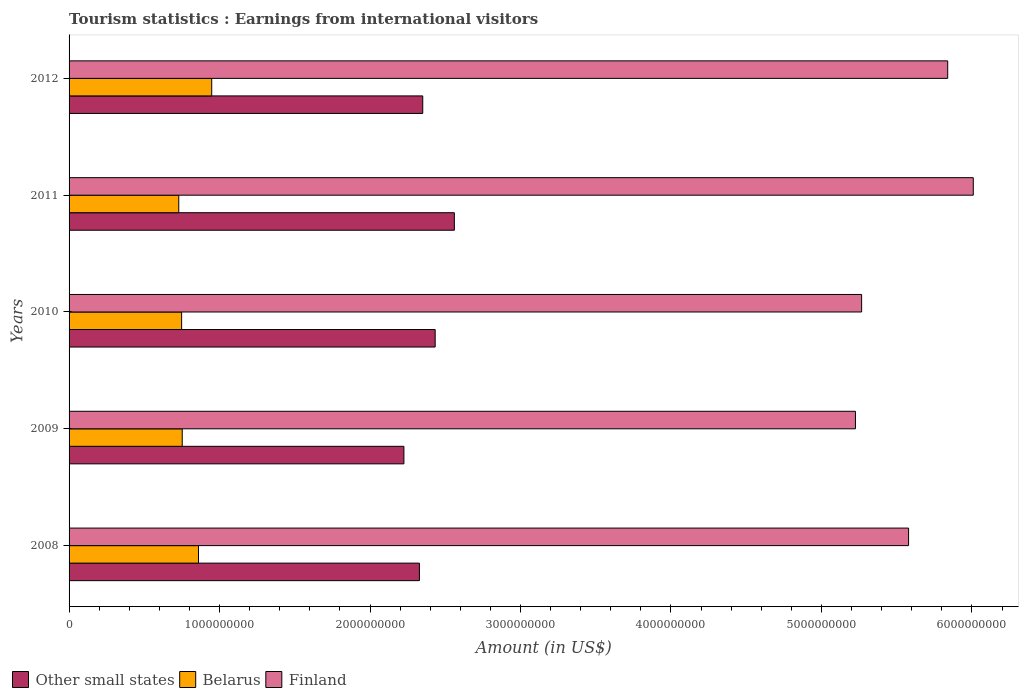How many different coloured bars are there?
Give a very brief answer. 3. Are the number of bars on each tick of the Y-axis equal?
Your answer should be compact. Yes. How many bars are there on the 4th tick from the bottom?
Offer a very short reply. 3. What is the label of the 1st group of bars from the top?
Your response must be concise. 2012. In how many cases, is the number of bars for a given year not equal to the number of legend labels?
Provide a succinct answer. 0. What is the earnings from international visitors in Other small states in 2012?
Provide a short and direct response. 2.35e+09. Across all years, what is the maximum earnings from international visitors in Other small states?
Offer a terse response. 2.56e+09. Across all years, what is the minimum earnings from international visitors in Other small states?
Ensure brevity in your answer.  2.23e+09. In which year was the earnings from international visitors in Other small states minimum?
Ensure brevity in your answer.  2009. What is the total earnings from international visitors in Finland in the graph?
Provide a short and direct response. 2.79e+1. What is the difference between the earnings from international visitors in Other small states in 2009 and that in 2010?
Provide a short and direct response. -2.08e+08. What is the difference between the earnings from international visitors in Belarus in 2008 and the earnings from international visitors in Finland in 2012?
Your answer should be compact. -4.98e+09. What is the average earnings from international visitors in Finland per year?
Keep it short and to the point. 5.58e+09. In the year 2011, what is the difference between the earnings from international visitors in Other small states and earnings from international visitors in Finland?
Make the answer very short. -3.45e+09. In how many years, is the earnings from international visitors in Belarus greater than 3600000000 US$?
Ensure brevity in your answer.  0. What is the ratio of the earnings from international visitors in Other small states in 2008 to that in 2012?
Offer a terse response. 0.99. Is the difference between the earnings from international visitors in Other small states in 2008 and 2010 greater than the difference between the earnings from international visitors in Finland in 2008 and 2010?
Ensure brevity in your answer.  No. What is the difference between the highest and the second highest earnings from international visitors in Other small states?
Give a very brief answer. 1.28e+08. What is the difference between the highest and the lowest earnings from international visitors in Other small states?
Provide a succinct answer. 3.35e+08. In how many years, is the earnings from international visitors in Belarus greater than the average earnings from international visitors in Belarus taken over all years?
Your response must be concise. 2. What does the 3rd bar from the top in 2012 represents?
Your answer should be compact. Other small states. What does the 3rd bar from the bottom in 2011 represents?
Offer a very short reply. Finland. Is it the case that in every year, the sum of the earnings from international visitors in Finland and earnings from international visitors in Belarus is greater than the earnings from international visitors in Other small states?
Your answer should be compact. Yes. How many bars are there?
Provide a succinct answer. 15. How many years are there in the graph?
Your answer should be compact. 5. Are the values on the major ticks of X-axis written in scientific E-notation?
Your answer should be very brief. No. Does the graph contain any zero values?
Your response must be concise. No. Does the graph contain grids?
Offer a terse response. No. What is the title of the graph?
Provide a short and direct response. Tourism statistics : Earnings from international visitors. Does "Guinea-Bissau" appear as one of the legend labels in the graph?
Provide a succinct answer. No. What is the label or title of the Y-axis?
Your answer should be compact. Years. What is the Amount (in US$) in Other small states in 2008?
Ensure brevity in your answer.  2.33e+09. What is the Amount (in US$) in Belarus in 2008?
Keep it short and to the point. 8.60e+08. What is the Amount (in US$) of Finland in 2008?
Your response must be concise. 5.58e+09. What is the Amount (in US$) in Other small states in 2009?
Your answer should be compact. 2.23e+09. What is the Amount (in US$) in Belarus in 2009?
Your answer should be very brief. 7.52e+08. What is the Amount (in US$) in Finland in 2009?
Your answer should be compact. 5.23e+09. What is the Amount (in US$) of Other small states in 2010?
Keep it short and to the point. 2.43e+09. What is the Amount (in US$) in Belarus in 2010?
Your answer should be compact. 7.48e+08. What is the Amount (in US$) in Finland in 2010?
Your answer should be very brief. 5.27e+09. What is the Amount (in US$) of Other small states in 2011?
Keep it short and to the point. 2.56e+09. What is the Amount (in US$) in Belarus in 2011?
Your answer should be compact. 7.29e+08. What is the Amount (in US$) in Finland in 2011?
Ensure brevity in your answer.  6.01e+09. What is the Amount (in US$) in Other small states in 2012?
Give a very brief answer. 2.35e+09. What is the Amount (in US$) in Belarus in 2012?
Provide a short and direct response. 9.48e+08. What is the Amount (in US$) of Finland in 2012?
Offer a very short reply. 5.84e+09. Across all years, what is the maximum Amount (in US$) in Other small states?
Offer a terse response. 2.56e+09. Across all years, what is the maximum Amount (in US$) in Belarus?
Ensure brevity in your answer.  9.48e+08. Across all years, what is the maximum Amount (in US$) of Finland?
Keep it short and to the point. 6.01e+09. Across all years, what is the minimum Amount (in US$) in Other small states?
Offer a very short reply. 2.23e+09. Across all years, what is the minimum Amount (in US$) of Belarus?
Provide a short and direct response. 7.29e+08. Across all years, what is the minimum Amount (in US$) in Finland?
Make the answer very short. 5.23e+09. What is the total Amount (in US$) of Other small states in the graph?
Ensure brevity in your answer.  1.19e+1. What is the total Amount (in US$) of Belarus in the graph?
Provide a succinct answer. 4.04e+09. What is the total Amount (in US$) of Finland in the graph?
Make the answer very short. 2.79e+1. What is the difference between the Amount (in US$) in Other small states in 2008 and that in 2009?
Provide a succinct answer. 1.03e+08. What is the difference between the Amount (in US$) in Belarus in 2008 and that in 2009?
Offer a terse response. 1.08e+08. What is the difference between the Amount (in US$) in Finland in 2008 and that in 2009?
Give a very brief answer. 3.53e+08. What is the difference between the Amount (in US$) of Other small states in 2008 and that in 2010?
Offer a terse response. -1.05e+08. What is the difference between the Amount (in US$) of Belarus in 2008 and that in 2010?
Keep it short and to the point. 1.12e+08. What is the difference between the Amount (in US$) of Finland in 2008 and that in 2010?
Make the answer very short. 3.12e+08. What is the difference between the Amount (in US$) of Other small states in 2008 and that in 2011?
Provide a succinct answer. -2.32e+08. What is the difference between the Amount (in US$) of Belarus in 2008 and that in 2011?
Your answer should be very brief. 1.31e+08. What is the difference between the Amount (in US$) of Finland in 2008 and that in 2011?
Give a very brief answer. -4.30e+08. What is the difference between the Amount (in US$) of Other small states in 2008 and that in 2012?
Keep it short and to the point. -2.21e+07. What is the difference between the Amount (in US$) of Belarus in 2008 and that in 2012?
Your answer should be very brief. -8.80e+07. What is the difference between the Amount (in US$) of Finland in 2008 and that in 2012?
Your response must be concise. -2.60e+08. What is the difference between the Amount (in US$) of Other small states in 2009 and that in 2010?
Provide a short and direct response. -2.08e+08. What is the difference between the Amount (in US$) in Finland in 2009 and that in 2010?
Your response must be concise. -4.10e+07. What is the difference between the Amount (in US$) of Other small states in 2009 and that in 2011?
Make the answer very short. -3.35e+08. What is the difference between the Amount (in US$) in Belarus in 2009 and that in 2011?
Your response must be concise. 2.30e+07. What is the difference between the Amount (in US$) of Finland in 2009 and that in 2011?
Provide a succinct answer. -7.83e+08. What is the difference between the Amount (in US$) of Other small states in 2009 and that in 2012?
Keep it short and to the point. -1.25e+08. What is the difference between the Amount (in US$) of Belarus in 2009 and that in 2012?
Give a very brief answer. -1.96e+08. What is the difference between the Amount (in US$) in Finland in 2009 and that in 2012?
Make the answer very short. -6.13e+08. What is the difference between the Amount (in US$) in Other small states in 2010 and that in 2011?
Make the answer very short. -1.28e+08. What is the difference between the Amount (in US$) of Belarus in 2010 and that in 2011?
Provide a short and direct response. 1.90e+07. What is the difference between the Amount (in US$) in Finland in 2010 and that in 2011?
Your response must be concise. -7.42e+08. What is the difference between the Amount (in US$) in Other small states in 2010 and that in 2012?
Offer a very short reply. 8.26e+07. What is the difference between the Amount (in US$) in Belarus in 2010 and that in 2012?
Your answer should be compact. -2.00e+08. What is the difference between the Amount (in US$) in Finland in 2010 and that in 2012?
Offer a terse response. -5.72e+08. What is the difference between the Amount (in US$) in Other small states in 2011 and that in 2012?
Offer a very short reply. 2.10e+08. What is the difference between the Amount (in US$) of Belarus in 2011 and that in 2012?
Offer a terse response. -2.19e+08. What is the difference between the Amount (in US$) of Finland in 2011 and that in 2012?
Offer a very short reply. 1.70e+08. What is the difference between the Amount (in US$) in Other small states in 2008 and the Amount (in US$) in Belarus in 2009?
Offer a terse response. 1.58e+09. What is the difference between the Amount (in US$) in Other small states in 2008 and the Amount (in US$) in Finland in 2009?
Your response must be concise. -2.90e+09. What is the difference between the Amount (in US$) in Belarus in 2008 and the Amount (in US$) in Finland in 2009?
Ensure brevity in your answer.  -4.37e+09. What is the difference between the Amount (in US$) of Other small states in 2008 and the Amount (in US$) of Belarus in 2010?
Your answer should be very brief. 1.58e+09. What is the difference between the Amount (in US$) in Other small states in 2008 and the Amount (in US$) in Finland in 2010?
Make the answer very short. -2.94e+09. What is the difference between the Amount (in US$) in Belarus in 2008 and the Amount (in US$) in Finland in 2010?
Your response must be concise. -4.41e+09. What is the difference between the Amount (in US$) in Other small states in 2008 and the Amount (in US$) in Belarus in 2011?
Keep it short and to the point. 1.60e+09. What is the difference between the Amount (in US$) in Other small states in 2008 and the Amount (in US$) in Finland in 2011?
Your answer should be compact. -3.68e+09. What is the difference between the Amount (in US$) of Belarus in 2008 and the Amount (in US$) of Finland in 2011?
Keep it short and to the point. -5.15e+09. What is the difference between the Amount (in US$) of Other small states in 2008 and the Amount (in US$) of Belarus in 2012?
Offer a terse response. 1.38e+09. What is the difference between the Amount (in US$) in Other small states in 2008 and the Amount (in US$) in Finland in 2012?
Provide a succinct answer. -3.51e+09. What is the difference between the Amount (in US$) of Belarus in 2008 and the Amount (in US$) of Finland in 2012?
Your answer should be very brief. -4.98e+09. What is the difference between the Amount (in US$) of Other small states in 2009 and the Amount (in US$) of Belarus in 2010?
Your answer should be very brief. 1.48e+09. What is the difference between the Amount (in US$) in Other small states in 2009 and the Amount (in US$) in Finland in 2010?
Your answer should be compact. -3.04e+09. What is the difference between the Amount (in US$) of Belarus in 2009 and the Amount (in US$) of Finland in 2010?
Provide a succinct answer. -4.52e+09. What is the difference between the Amount (in US$) of Other small states in 2009 and the Amount (in US$) of Belarus in 2011?
Your answer should be very brief. 1.50e+09. What is the difference between the Amount (in US$) in Other small states in 2009 and the Amount (in US$) in Finland in 2011?
Offer a very short reply. -3.78e+09. What is the difference between the Amount (in US$) of Belarus in 2009 and the Amount (in US$) of Finland in 2011?
Give a very brief answer. -5.26e+09. What is the difference between the Amount (in US$) of Other small states in 2009 and the Amount (in US$) of Belarus in 2012?
Ensure brevity in your answer.  1.28e+09. What is the difference between the Amount (in US$) of Other small states in 2009 and the Amount (in US$) of Finland in 2012?
Give a very brief answer. -3.61e+09. What is the difference between the Amount (in US$) in Belarus in 2009 and the Amount (in US$) in Finland in 2012?
Make the answer very short. -5.09e+09. What is the difference between the Amount (in US$) of Other small states in 2010 and the Amount (in US$) of Belarus in 2011?
Your answer should be compact. 1.70e+09. What is the difference between the Amount (in US$) of Other small states in 2010 and the Amount (in US$) of Finland in 2011?
Your answer should be compact. -3.58e+09. What is the difference between the Amount (in US$) of Belarus in 2010 and the Amount (in US$) of Finland in 2011?
Give a very brief answer. -5.26e+09. What is the difference between the Amount (in US$) of Other small states in 2010 and the Amount (in US$) of Belarus in 2012?
Ensure brevity in your answer.  1.48e+09. What is the difference between the Amount (in US$) in Other small states in 2010 and the Amount (in US$) in Finland in 2012?
Make the answer very short. -3.41e+09. What is the difference between the Amount (in US$) of Belarus in 2010 and the Amount (in US$) of Finland in 2012?
Make the answer very short. -5.09e+09. What is the difference between the Amount (in US$) in Other small states in 2011 and the Amount (in US$) in Belarus in 2012?
Your response must be concise. 1.61e+09. What is the difference between the Amount (in US$) of Other small states in 2011 and the Amount (in US$) of Finland in 2012?
Offer a terse response. -3.28e+09. What is the difference between the Amount (in US$) in Belarus in 2011 and the Amount (in US$) in Finland in 2012?
Provide a succinct answer. -5.11e+09. What is the average Amount (in US$) of Other small states per year?
Your response must be concise. 2.38e+09. What is the average Amount (in US$) in Belarus per year?
Give a very brief answer. 8.07e+08. What is the average Amount (in US$) of Finland per year?
Your answer should be very brief. 5.58e+09. In the year 2008, what is the difference between the Amount (in US$) in Other small states and Amount (in US$) in Belarus?
Ensure brevity in your answer.  1.47e+09. In the year 2008, what is the difference between the Amount (in US$) of Other small states and Amount (in US$) of Finland?
Offer a terse response. -3.25e+09. In the year 2008, what is the difference between the Amount (in US$) of Belarus and Amount (in US$) of Finland?
Provide a succinct answer. -4.72e+09. In the year 2009, what is the difference between the Amount (in US$) of Other small states and Amount (in US$) of Belarus?
Your response must be concise. 1.47e+09. In the year 2009, what is the difference between the Amount (in US$) in Other small states and Amount (in US$) in Finland?
Provide a short and direct response. -3.00e+09. In the year 2009, what is the difference between the Amount (in US$) in Belarus and Amount (in US$) in Finland?
Your answer should be very brief. -4.47e+09. In the year 2010, what is the difference between the Amount (in US$) of Other small states and Amount (in US$) of Belarus?
Offer a terse response. 1.68e+09. In the year 2010, what is the difference between the Amount (in US$) in Other small states and Amount (in US$) in Finland?
Ensure brevity in your answer.  -2.83e+09. In the year 2010, what is the difference between the Amount (in US$) of Belarus and Amount (in US$) of Finland?
Keep it short and to the point. -4.52e+09. In the year 2011, what is the difference between the Amount (in US$) in Other small states and Amount (in US$) in Belarus?
Offer a very short reply. 1.83e+09. In the year 2011, what is the difference between the Amount (in US$) in Other small states and Amount (in US$) in Finland?
Offer a terse response. -3.45e+09. In the year 2011, what is the difference between the Amount (in US$) in Belarus and Amount (in US$) in Finland?
Provide a short and direct response. -5.28e+09. In the year 2012, what is the difference between the Amount (in US$) in Other small states and Amount (in US$) in Belarus?
Provide a succinct answer. 1.40e+09. In the year 2012, what is the difference between the Amount (in US$) of Other small states and Amount (in US$) of Finland?
Offer a very short reply. -3.49e+09. In the year 2012, what is the difference between the Amount (in US$) in Belarus and Amount (in US$) in Finland?
Your response must be concise. -4.89e+09. What is the ratio of the Amount (in US$) of Other small states in 2008 to that in 2009?
Your answer should be compact. 1.05. What is the ratio of the Amount (in US$) of Belarus in 2008 to that in 2009?
Make the answer very short. 1.14. What is the ratio of the Amount (in US$) of Finland in 2008 to that in 2009?
Provide a short and direct response. 1.07. What is the ratio of the Amount (in US$) of Other small states in 2008 to that in 2010?
Provide a short and direct response. 0.96. What is the ratio of the Amount (in US$) of Belarus in 2008 to that in 2010?
Your response must be concise. 1.15. What is the ratio of the Amount (in US$) in Finland in 2008 to that in 2010?
Provide a short and direct response. 1.06. What is the ratio of the Amount (in US$) of Other small states in 2008 to that in 2011?
Provide a short and direct response. 0.91. What is the ratio of the Amount (in US$) of Belarus in 2008 to that in 2011?
Make the answer very short. 1.18. What is the ratio of the Amount (in US$) in Finland in 2008 to that in 2011?
Give a very brief answer. 0.93. What is the ratio of the Amount (in US$) in Other small states in 2008 to that in 2012?
Make the answer very short. 0.99. What is the ratio of the Amount (in US$) of Belarus in 2008 to that in 2012?
Your answer should be very brief. 0.91. What is the ratio of the Amount (in US$) of Finland in 2008 to that in 2012?
Offer a terse response. 0.96. What is the ratio of the Amount (in US$) in Other small states in 2009 to that in 2010?
Offer a very short reply. 0.91. What is the ratio of the Amount (in US$) in Belarus in 2009 to that in 2010?
Offer a very short reply. 1.01. What is the ratio of the Amount (in US$) in Other small states in 2009 to that in 2011?
Your answer should be very brief. 0.87. What is the ratio of the Amount (in US$) of Belarus in 2009 to that in 2011?
Offer a terse response. 1.03. What is the ratio of the Amount (in US$) of Finland in 2009 to that in 2011?
Your answer should be compact. 0.87. What is the ratio of the Amount (in US$) of Other small states in 2009 to that in 2012?
Keep it short and to the point. 0.95. What is the ratio of the Amount (in US$) of Belarus in 2009 to that in 2012?
Provide a short and direct response. 0.79. What is the ratio of the Amount (in US$) in Finland in 2009 to that in 2012?
Ensure brevity in your answer.  0.9. What is the ratio of the Amount (in US$) in Other small states in 2010 to that in 2011?
Provide a succinct answer. 0.95. What is the ratio of the Amount (in US$) of Belarus in 2010 to that in 2011?
Your answer should be very brief. 1.03. What is the ratio of the Amount (in US$) in Finland in 2010 to that in 2011?
Keep it short and to the point. 0.88. What is the ratio of the Amount (in US$) in Other small states in 2010 to that in 2012?
Your answer should be compact. 1.04. What is the ratio of the Amount (in US$) of Belarus in 2010 to that in 2012?
Make the answer very short. 0.79. What is the ratio of the Amount (in US$) of Finland in 2010 to that in 2012?
Your response must be concise. 0.9. What is the ratio of the Amount (in US$) in Other small states in 2011 to that in 2012?
Your answer should be compact. 1.09. What is the ratio of the Amount (in US$) of Belarus in 2011 to that in 2012?
Give a very brief answer. 0.77. What is the ratio of the Amount (in US$) in Finland in 2011 to that in 2012?
Your answer should be very brief. 1.03. What is the difference between the highest and the second highest Amount (in US$) in Other small states?
Your answer should be very brief. 1.28e+08. What is the difference between the highest and the second highest Amount (in US$) in Belarus?
Offer a terse response. 8.80e+07. What is the difference between the highest and the second highest Amount (in US$) in Finland?
Make the answer very short. 1.70e+08. What is the difference between the highest and the lowest Amount (in US$) in Other small states?
Offer a very short reply. 3.35e+08. What is the difference between the highest and the lowest Amount (in US$) in Belarus?
Your response must be concise. 2.19e+08. What is the difference between the highest and the lowest Amount (in US$) in Finland?
Your answer should be compact. 7.83e+08. 